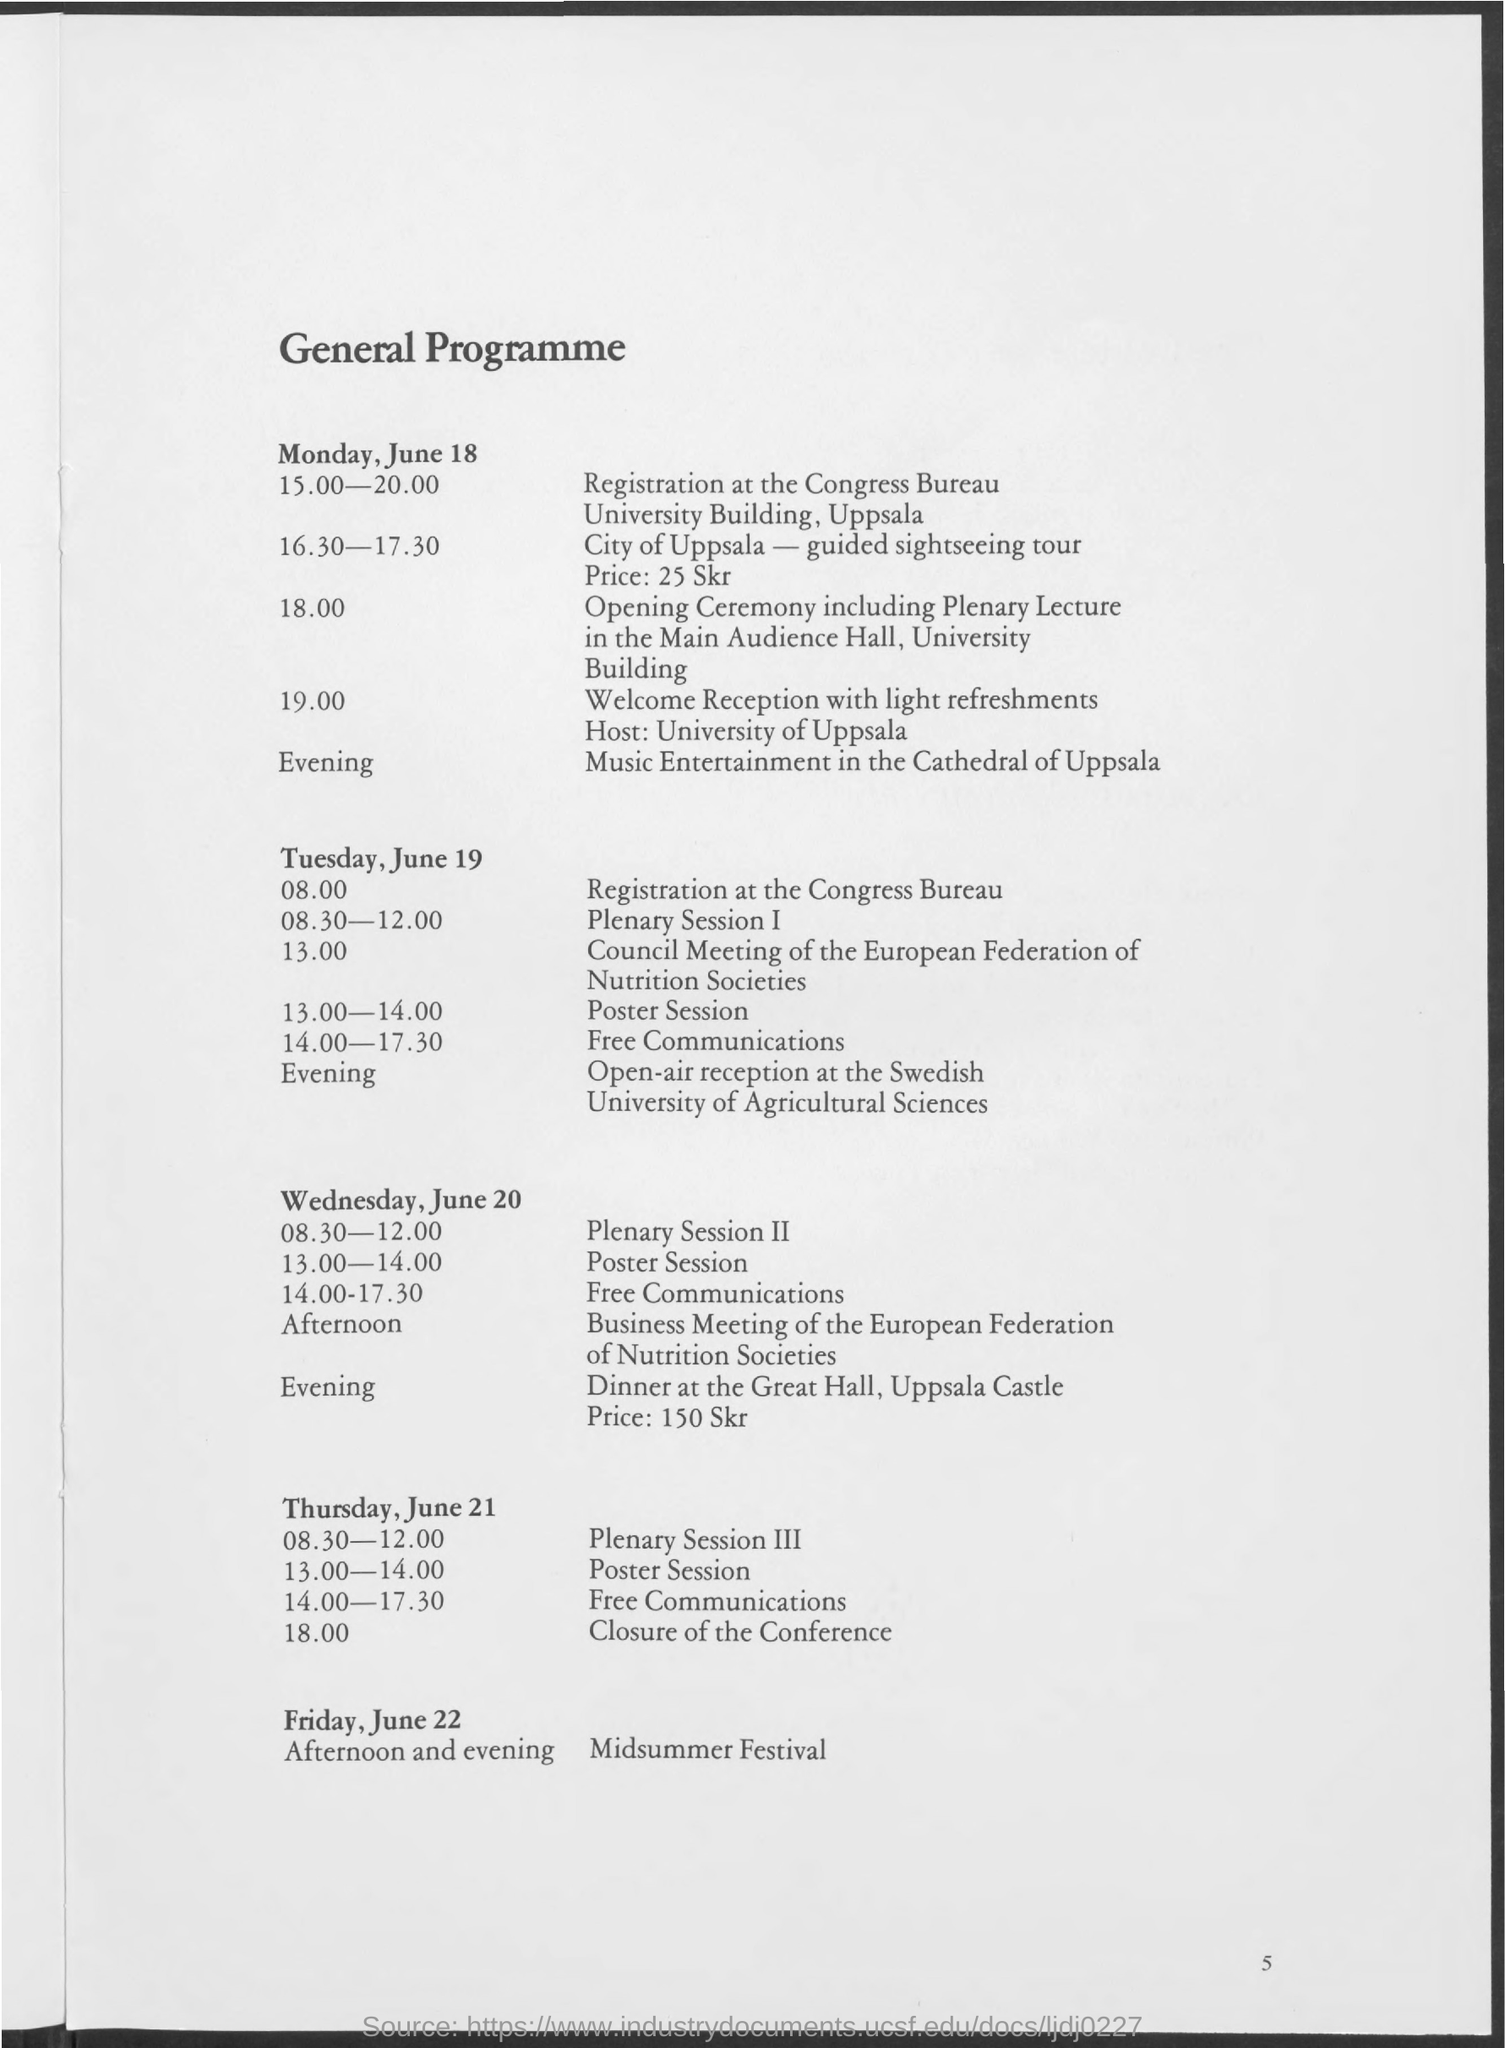List a handful of essential elements in this visual. The heading of the page is 'General Programme'. 